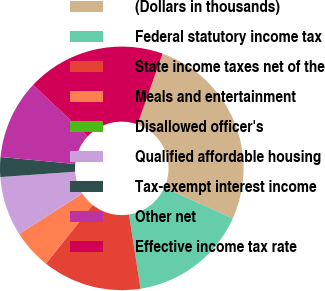<chart> <loc_0><loc_0><loc_500><loc_500><pie_chart><fcel>(Dollars in thousands)<fcel>Federal statutory income tax<fcel>State income taxes net of the<fcel>Meals and entertainment<fcel>Disallowed officer's<fcel>Qualified affordable housing<fcel>Tax-exempt interest income<fcel>Other net<fcel>Effective income tax rate<nl><fcel>26.31%<fcel>15.79%<fcel>13.16%<fcel>5.26%<fcel>0.0%<fcel>7.9%<fcel>2.63%<fcel>10.53%<fcel>18.42%<nl></chart> 